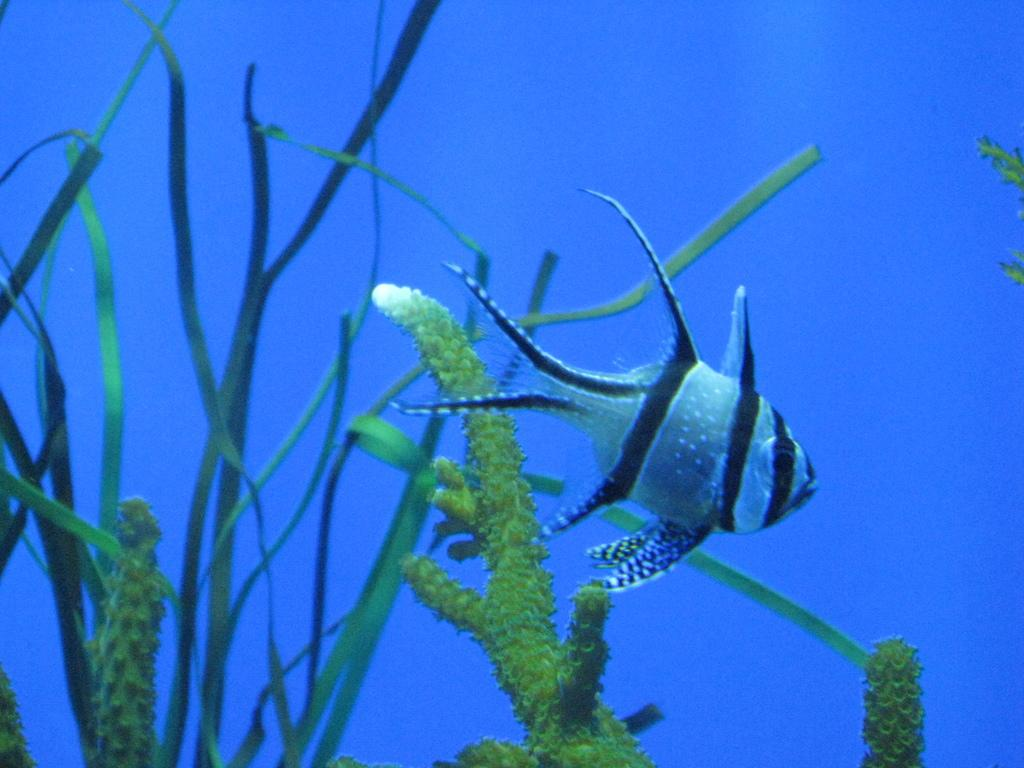What type of animal is in the image? There is a fish in the image. What else can be seen in the water with the fish? There are plants in the water in the image. What color is the background of the image? The background of the image is blue. What type of cracker is floating on the water in the image? There is no cracker present in the image; it features a fish and plants in the water. 